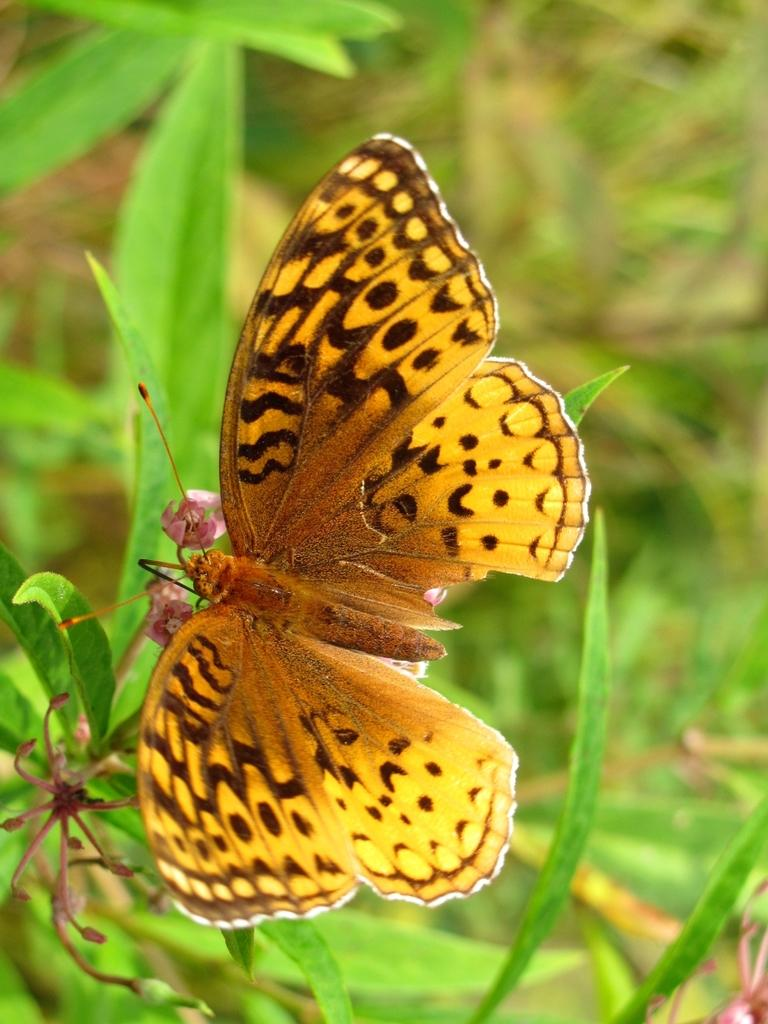What is the main subject of the image? The main subject of the image is a butterfly on flowers. What type of vegetation is present in the image? There are green leaves in the image. How many bikes can be seen parked near the lake in the image? There is no reference to bikes, a lake, or any parked vehicles in the image. 